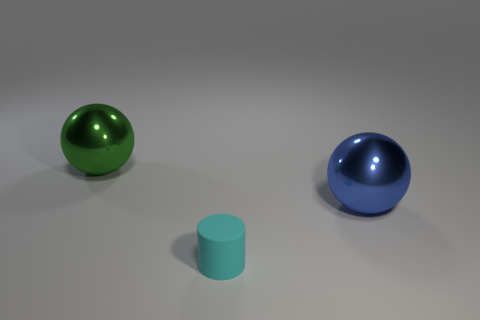Add 2 cubes. How many objects exist? 5 Subtract all spheres. How many objects are left? 1 Subtract all cyan matte things. Subtract all big blue metal objects. How many objects are left? 1 Add 3 matte cylinders. How many matte cylinders are left? 4 Add 1 blue objects. How many blue objects exist? 2 Subtract 0 blue cubes. How many objects are left? 3 